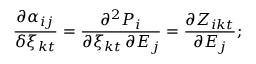Convert formula to latex. <formula><loc_0><loc_0><loc_500><loc_500>\frac { \partial \alpha _ { i j } } { \delta \xi _ { k t } } = \frac { \partial ^ { 2 } P _ { i } } { \partial \xi _ { k t } \, \partial E _ { j } } = \frac { \partial Z _ { i k t } } { \partial E _ { j } } ;</formula> 